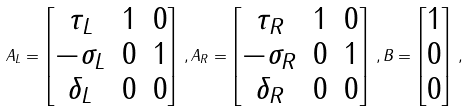<formula> <loc_0><loc_0><loc_500><loc_500>A _ { L } = \begin{bmatrix} \tau _ { L } & 1 & 0 \\ - \sigma _ { L } & 0 & 1 \\ \delta _ { L } & 0 & 0 \end{bmatrix} \, , A _ { R } = \begin{bmatrix} \tau _ { R } & 1 & 0 \\ - \sigma _ { R } & 0 & 1 \\ \delta _ { R } & 0 & 0 \end{bmatrix} \, , B = \begin{bmatrix} 1 \\ 0 \\ 0 \end{bmatrix} \, ,</formula> 